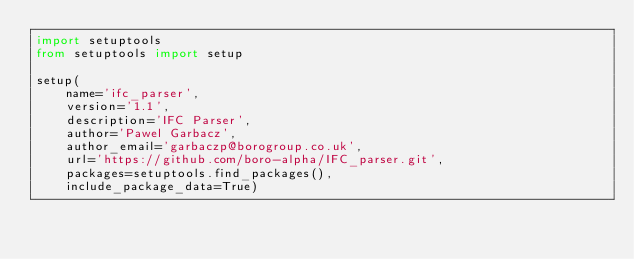Convert code to text. <code><loc_0><loc_0><loc_500><loc_500><_Python_>import setuptools
from setuptools import setup

setup(
    name='ifc_parser',
    version='1.1',
    description='IFC Parser',
    author='Pawel Garbacz',
    author_email='garbaczp@borogroup.co.uk',
    url='https://github.com/boro-alpha/IFC_parser.git',
    packages=setuptools.find_packages(),
    include_package_data=True)
</code> 